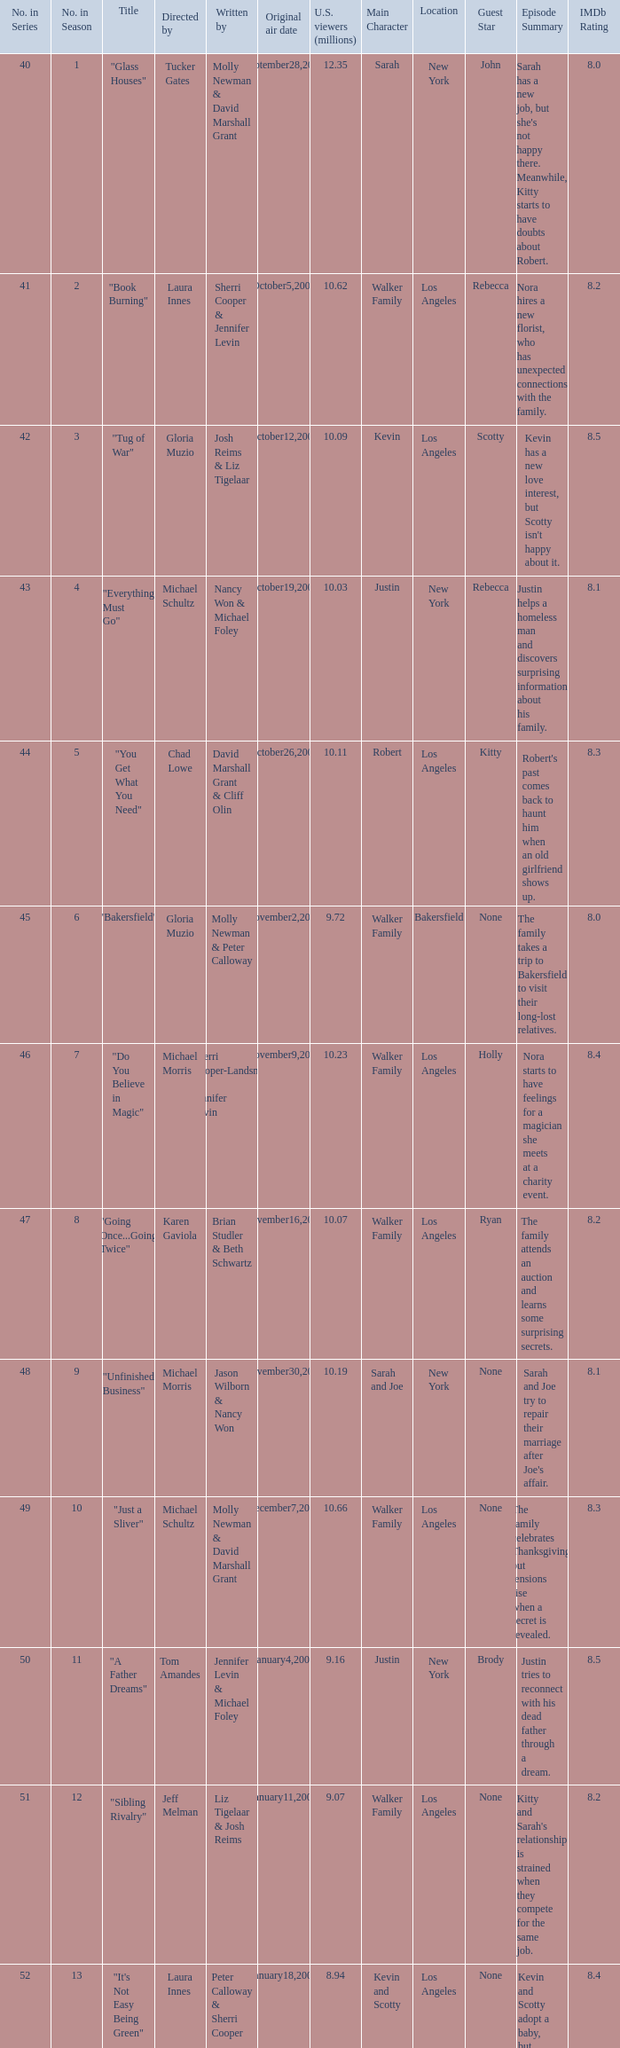When did the episode viewed by 10.50 millions of people in the US run for the first time? March8,2009. Would you mind parsing the complete table? {'header': ['No. in Series', 'No. in Season', 'Title', 'Directed by', 'Written by', 'Original air date', 'U.S. viewers (millions)', 'Main Character', 'Location', 'Guest Star', 'Episode Summary', 'IMDb Rating'], 'rows': [['40', '1', '"Glass Houses"', 'Tucker Gates', 'Molly Newman & David Marshall Grant', 'September28,2008', '12.35', 'Sarah', 'New York', 'John', "Sarah has a new job, but she's not happy there. Meanwhile, Kitty starts to have doubts about Robert.", '8.0'], ['41', '2', '"Book Burning"', 'Laura Innes', 'Sherri Cooper & Jennifer Levin', 'October5,2008', '10.62', 'Walker Family', 'Los Angeles', 'Rebecca', 'Nora hires a new florist, who has unexpected connections with the family.', '8.2'], ['42', '3', '"Tug of War"', 'Gloria Muzio', 'Josh Reims & Liz Tigelaar', 'October12,2008', '10.09', 'Kevin', 'Los Angeles', 'Scotty', "Kevin has a new love interest, but Scotty isn't happy about it.", '8.5'], ['43', '4', '"Everything Must Go"', 'Michael Schultz', 'Nancy Won & Michael Foley', 'October19,2008', '10.03', 'Justin', 'New York', 'Rebecca', 'Justin helps a homeless man and discovers surprising information about his family.', '8.1'], ['44', '5', '"You Get What You Need"', 'Chad Lowe', 'David Marshall Grant & Cliff Olin', 'October26,2008', '10.11', 'Robert', 'Los Angeles', 'Kitty', "Robert's past comes back to haunt him when an old girlfriend shows up.", '8.3'], ['45', '6', '"Bakersfield"', 'Gloria Muzio', 'Molly Newman & Peter Calloway', 'November2,2008', '9.72', 'Walker Family', 'Bakersfield', 'None', 'The family takes a trip to Bakersfield to visit their long-lost relatives.', '8.0'], ['46', '7', '"Do You Believe in Magic"', 'Michael Morris', 'Sherri Cooper-Landsman & Jennifer Levin', 'November9,2008', '10.23', 'Walker Family', 'Los Angeles', 'Holly', 'Nora starts to have feelings for a magician she meets at a charity event.', '8.4'], ['47', '8', '"Going Once...Going Twice"', 'Karen Gaviola', 'Brian Studler & Beth Schwartz', 'November16,2008', '10.07', 'Walker Family', 'Los Angeles', 'Ryan', 'The family attends an auction and learns some surprising secrets.', '8.2'], ['48', '9', '"Unfinished Business"', 'Michael Morris', 'Jason Wilborn & Nancy Won', 'November30,2008', '10.19', 'Sarah and Joe', 'New York', 'None', "Sarah and Joe try to repair their marriage after Joe's affair.", '8.1'], ['49', '10', '"Just a Sliver"', 'Michael Schultz', 'Molly Newman & David Marshall Grant', 'December7,2008', '10.66', 'Walker Family', 'Los Angeles', 'None', 'The family celebrates Thanksgiving, but tensions rise when a secret is revealed.', '8.3'], ['50', '11', '"A Father Dreams"', 'Tom Amandes', 'Jennifer Levin & Michael Foley', 'January4,2009', '9.16', 'Justin', 'New York', 'Brody', 'Justin tries to reconnect with his dead father through a dream.', '8.5'], ['51', '12', '"Sibling Rivalry"', 'Jeff Melman', 'Liz Tigelaar & Josh Reims', 'January11,2009', '9.07', 'Walker Family', 'Los Angeles', 'None', "Kitty and Sarah's relationship is strained when they compete for the same job.", '8.2'], ['52', '13', '"It\'s Not Easy Being Green"', 'Laura Innes', 'Peter Calloway & Sherri Cooper', 'January18,2009', '8.94', 'Kevin and Scotty', 'Los Angeles', 'None', 'Kevin and Scotty adopt a baby, but their happiness is short-lived.', '8.4'], ['53', '14', '"Owning It"', 'Bethany Rooney', 'Cliff Olin & David Marshall Grant', 'February8,2009', '9.33', 'Walker Family', 'Los Angeles', 'None', 'Nora takes a job and becomes a success, but her family is suspicious.', '8.1'], ['54', '15', '"Lost & Found"', 'David Paymer', 'Michael Foley & Jennifer Levin', 'February15,2009', '9.07', 'Sarah and Rebecca', 'New York', 'None', 'Sarah and Rebecca try to find their father, but make a shocking discovery.', '8.3'], ['55', '16', '"Troubled Waters, Part One"', 'Ken Olin', 'Monica Owusu-Breen & Sherri Cooper-Landsman', 'March1,2009', '11.93', 'Walker Family', 'Ojai', 'None', 'The family faces financial troubles and must decide whether to sell the winery.', '8.5'], ['56', '17', '"Troubled Waters, Part Two"', 'Ken Olin', 'David Marshall Grant & Molly Newman', 'March1,2009', '11.93', 'Walker Family', 'Ojai', 'None', 'The family makes a decision about the winery, but someone has a secret agenda.', '8.5'], ['57', '18', '"Taking Sides"', 'Michael Morris', 'Michael Foley & Beth Schwartz', 'March8,2009', '10.50', 'Nora', 'Los Angeles', 'Isaac', 'Nora reconnects with an old flame, but her children are suspicious.', '8.4'], ['58', '19', '"Spring Broken"', 'Richard Coad', 'Sherri Cooper-Landsman & Brian Studler', 'March15,2009', '10.58', 'Walker Family', 'Palm Springs', 'None', 'The family takes a trip to Palm Springs for spring break.', '8.1'], ['59', '20', '"Missing"', 'Michael Schultz', 'Jason Wilborn & Nancy Won', 'March22,2009', '10.81', 'Justin', 'New York', 'None', 'Justin goes missing and his family races to find him.', '8.3'], ['60', '21', '"S3X"', 'Laura Innes', 'Cliff Olin & David Marshall Grant', 'April19,2009', '9.63', 'Walker Family', 'Los Angeles', 'None', 'The family deals with issues of sex and sexuality.', '8.2'], ['61', '22', '"Julia"', 'Michael Morris', 'Molly Newman & Michael Foley', 'April26,2009', '9.63', 'Walker Family', 'Los Angeles', 'None', 'The family deals with the aftermath of a tragic event.', '8.4'], ['62', '23', '"Let\'s Call The Whole Thing Off"', 'Laura Innes', 'Peter Calloway & Daniel Silk', 'May3,2009', '9.22', 'Walker Family', 'Los Angeles', 'None', 'The family must come together to deal with a crisis.', '8.5']]} 